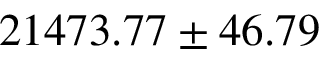Convert formula to latex. <formula><loc_0><loc_0><loc_500><loc_500>2 1 4 7 3 . 7 7 \pm 4 6 . 7 9</formula> 